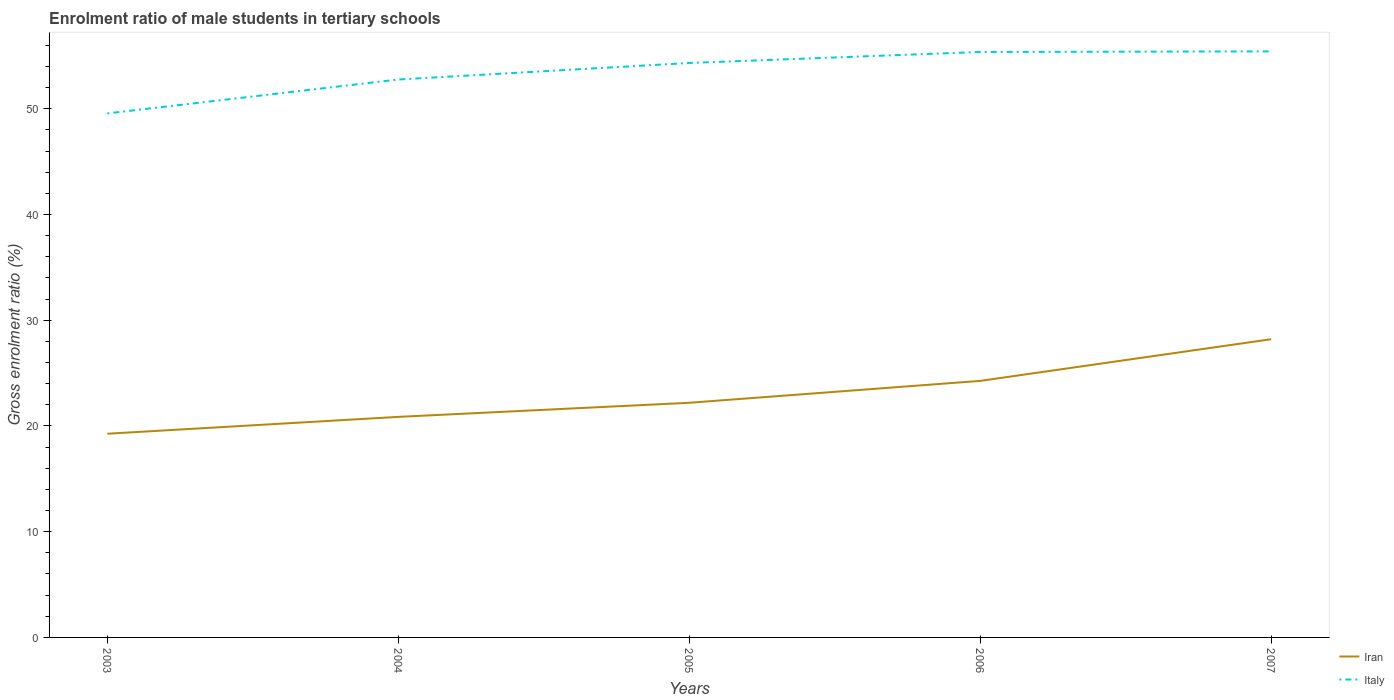Is the number of lines equal to the number of legend labels?
Offer a very short reply. Yes. Across all years, what is the maximum enrolment ratio of male students in tertiary schools in Italy?
Offer a very short reply. 49.56. What is the total enrolment ratio of male students in tertiary schools in Iran in the graph?
Ensure brevity in your answer.  -1.59. What is the difference between the highest and the second highest enrolment ratio of male students in tertiary schools in Italy?
Offer a terse response. 5.87. How many lines are there?
Provide a short and direct response. 2. How many years are there in the graph?
Your answer should be compact. 5. What is the difference between two consecutive major ticks on the Y-axis?
Provide a short and direct response. 10. Does the graph contain any zero values?
Make the answer very short. No. How many legend labels are there?
Provide a succinct answer. 2. How are the legend labels stacked?
Offer a very short reply. Vertical. What is the title of the graph?
Ensure brevity in your answer.  Enrolment ratio of male students in tertiary schools. Does "Morocco" appear as one of the legend labels in the graph?
Your answer should be compact. No. What is the label or title of the Y-axis?
Ensure brevity in your answer.  Gross enrolment ratio (%). What is the Gross enrolment ratio (%) in Iran in 2003?
Give a very brief answer. 19.27. What is the Gross enrolment ratio (%) of Italy in 2003?
Offer a terse response. 49.56. What is the Gross enrolment ratio (%) of Iran in 2004?
Offer a terse response. 20.86. What is the Gross enrolment ratio (%) of Italy in 2004?
Make the answer very short. 52.77. What is the Gross enrolment ratio (%) of Iran in 2005?
Your response must be concise. 22.19. What is the Gross enrolment ratio (%) in Italy in 2005?
Give a very brief answer. 54.33. What is the Gross enrolment ratio (%) in Iran in 2006?
Offer a terse response. 24.26. What is the Gross enrolment ratio (%) of Italy in 2006?
Offer a very short reply. 55.37. What is the Gross enrolment ratio (%) of Iran in 2007?
Offer a very short reply. 28.2. What is the Gross enrolment ratio (%) of Italy in 2007?
Offer a very short reply. 55.43. Across all years, what is the maximum Gross enrolment ratio (%) in Iran?
Keep it short and to the point. 28.2. Across all years, what is the maximum Gross enrolment ratio (%) of Italy?
Offer a terse response. 55.43. Across all years, what is the minimum Gross enrolment ratio (%) of Iran?
Provide a succinct answer. 19.27. Across all years, what is the minimum Gross enrolment ratio (%) in Italy?
Ensure brevity in your answer.  49.56. What is the total Gross enrolment ratio (%) in Iran in the graph?
Make the answer very short. 114.79. What is the total Gross enrolment ratio (%) of Italy in the graph?
Your answer should be compact. 267.46. What is the difference between the Gross enrolment ratio (%) in Iran in 2003 and that in 2004?
Give a very brief answer. -1.59. What is the difference between the Gross enrolment ratio (%) of Italy in 2003 and that in 2004?
Give a very brief answer. -3.21. What is the difference between the Gross enrolment ratio (%) in Iran in 2003 and that in 2005?
Make the answer very short. -2.93. What is the difference between the Gross enrolment ratio (%) of Italy in 2003 and that in 2005?
Your response must be concise. -4.77. What is the difference between the Gross enrolment ratio (%) in Iran in 2003 and that in 2006?
Make the answer very short. -5. What is the difference between the Gross enrolment ratio (%) of Italy in 2003 and that in 2006?
Ensure brevity in your answer.  -5.81. What is the difference between the Gross enrolment ratio (%) in Iran in 2003 and that in 2007?
Your answer should be very brief. -8.94. What is the difference between the Gross enrolment ratio (%) of Italy in 2003 and that in 2007?
Provide a succinct answer. -5.87. What is the difference between the Gross enrolment ratio (%) in Iran in 2004 and that in 2005?
Give a very brief answer. -1.33. What is the difference between the Gross enrolment ratio (%) in Italy in 2004 and that in 2005?
Provide a short and direct response. -1.56. What is the difference between the Gross enrolment ratio (%) in Iran in 2004 and that in 2006?
Offer a very short reply. -3.4. What is the difference between the Gross enrolment ratio (%) in Italy in 2004 and that in 2006?
Offer a terse response. -2.6. What is the difference between the Gross enrolment ratio (%) of Iran in 2004 and that in 2007?
Ensure brevity in your answer.  -7.35. What is the difference between the Gross enrolment ratio (%) in Italy in 2004 and that in 2007?
Keep it short and to the point. -2.66. What is the difference between the Gross enrolment ratio (%) in Iran in 2005 and that in 2006?
Offer a very short reply. -2.07. What is the difference between the Gross enrolment ratio (%) of Italy in 2005 and that in 2006?
Ensure brevity in your answer.  -1.04. What is the difference between the Gross enrolment ratio (%) in Iran in 2005 and that in 2007?
Your response must be concise. -6.01. What is the difference between the Gross enrolment ratio (%) in Italy in 2005 and that in 2007?
Make the answer very short. -1.1. What is the difference between the Gross enrolment ratio (%) of Iran in 2006 and that in 2007?
Your answer should be very brief. -3.94. What is the difference between the Gross enrolment ratio (%) in Italy in 2006 and that in 2007?
Your response must be concise. -0.06. What is the difference between the Gross enrolment ratio (%) in Iran in 2003 and the Gross enrolment ratio (%) in Italy in 2004?
Your answer should be compact. -33.5. What is the difference between the Gross enrolment ratio (%) in Iran in 2003 and the Gross enrolment ratio (%) in Italy in 2005?
Keep it short and to the point. -35.07. What is the difference between the Gross enrolment ratio (%) of Iran in 2003 and the Gross enrolment ratio (%) of Italy in 2006?
Offer a terse response. -36.11. What is the difference between the Gross enrolment ratio (%) in Iran in 2003 and the Gross enrolment ratio (%) in Italy in 2007?
Provide a succinct answer. -36.16. What is the difference between the Gross enrolment ratio (%) of Iran in 2004 and the Gross enrolment ratio (%) of Italy in 2005?
Give a very brief answer. -33.47. What is the difference between the Gross enrolment ratio (%) of Iran in 2004 and the Gross enrolment ratio (%) of Italy in 2006?
Make the answer very short. -34.51. What is the difference between the Gross enrolment ratio (%) in Iran in 2004 and the Gross enrolment ratio (%) in Italy in 2007?
Your answer should be very brief. -34.57. What is the difference between the Gross enrolment ratio (%) of Iran in 2005 and the Gross enrolment ratio (%) of Italy in 2006?
Provide a short and direct response. -33.18. What is the difference between the Gross enrolment ratio (%) in Iran in 2005 and the Gross enrolment ratio (%) in Italy in 2007?
Your answer should be very brief. -33.24. What is the difference between the Gross enrolment ratio (%) in Iran in 2006 and the Gross enrolment ratio (%) in Italy in 2007?
Your answer should be compact. -31.16. What is the average Gross enrolment ratio (%) of Iran per year?
Ensure brevity in your answer.  22.96. What is the average Gross enrolment ratio (%) of Italy per year?
Provide a succinct answer. 53.49. In the year 2003, what is the difference between the Gross enrolment ratio (%) in Iran and Gross enrolment ratio (%) in Italy?
Provide a short and direct response. -30.29. In the year 2004, what is the difference between the Gross enrolment ratio (%) of Iran and Gross enrolment ratio (%) of Italy?
Your answer should be compact. -31.91. In the year 2005, what is the difference between the Gross enrolment ratio (%) of Iran and Gross enrolment ratio (%) of Italy?
Your response must be concise. -32.14. In the year 2006, what is the difference between the Gross enrolment ratio (%) of Iran and Gross enrolment ratio (%) of Italy?
Keep it short and to the point. -31.11. In the year 2007, what is the difference between the Gross enrolment ratio (%) of Iran and Gross enrolment ratio (%) of Italy?
Your response must be concise. -27.22. What is the ratio of the Gross enrolment ratio (%) in Iran in 2003 to that in 2004?
Give a very brief answer. 0.92. What is the ratio of the Gross enrolment ratio (%) in Italy in 2003 to that in 2004?
Provide a short and direct response. 0.94. What is the ratio of the Gross enrolment ratio (%) in Iran in 2003 to that in 2005?
Offer a very short reply. 0.87. What is the ratio of the Gross enrolment ratio (%) in Italy in 2003 to that in 2005?
Your response must be concise. 0.91. What is the ratio of the Gross enrolment ratio (%) in Iran in 2003 to that in 2006?
Keep it short and to the point. 0.79. What is the ratio of the Gross enrolment ratio (%) in Italy in 2003 to that in 2006?
Give a very brief answer. 0.9. What is the ratio of the Gross enrolment ratio (%) of Iran in 2003 to that in 2007?
Provide a short and direct response. 0.68. What is the ratio of the Gross enrolment ratio (%) of Italy in 2003 to that in 2007?
Offer a very short reply. 0.89. What is the ratio of the Gross enrolment ratio (%) in Iran in 2004 to that in 2005?
Keep it short and to the point. 0.94. What is the ratio of the Gross enrolment ratio (%) in Italy in 2004 to that in 2005?
Offer a terse response. 0.97. What is the ratio of the Gross enrolment ratio (%) of Iran in 2004 to that in 2006?
Ensure brevity in your answer.  0.86. What is the ratio of the Gross enrolment ratio (%) in Italy in 2004 to that in 2006?
Offer a very short reply. 0.95. What is the ratio of the Gross enrolment ratio (%) of Iran in 2004 to that in 2007?
Offer a terse response. 0.74. What is the ratio of the Gross enrolment ratio (%) of Italy in 2004 to that in 2007?
Give a very brief answer. 0.95. What is the ratio of the Gross enrolment ratio (%) of Iran in 2005 to that in 2006?
Your answer should be compact. 0.91. What is the ratio of the Gross enrolment ratio (%) in Italy in 2005 to that in 2006?
Your response must be concise. 0.98. What is the ratio of the Gross enrolment ratio (%) in Iran in 2005 to that in 2007?
Make the answer very short. 0.79. What is the ratio of the Gross enrolment ratio (%) of Italy in 2005 to that in 2007?
Your answer should be very brief. 0.98. What is the ratio of the Gross enrolment ratio (%) in Iran in 2006 to that in 2007?
Your answer should be compact. 0.86. What is the difference between the highest and the second highest Gross enrolment ratio (%) in Iran?
Offer a terse response. 3.94. What is the difference between the highest and the second highest Gross enrolment ratio (%) in Italy?
Provide a succinct answer. 0.06. What is the difference between the highest and the lowest Gross enrolment ratio (%) in Iran?
Keep it short and to the point. 8.94. What is the difference between the highest and the lowest Gross enrolment ratio (%) of Italy?
Provide a succinct answer. 5.87. 